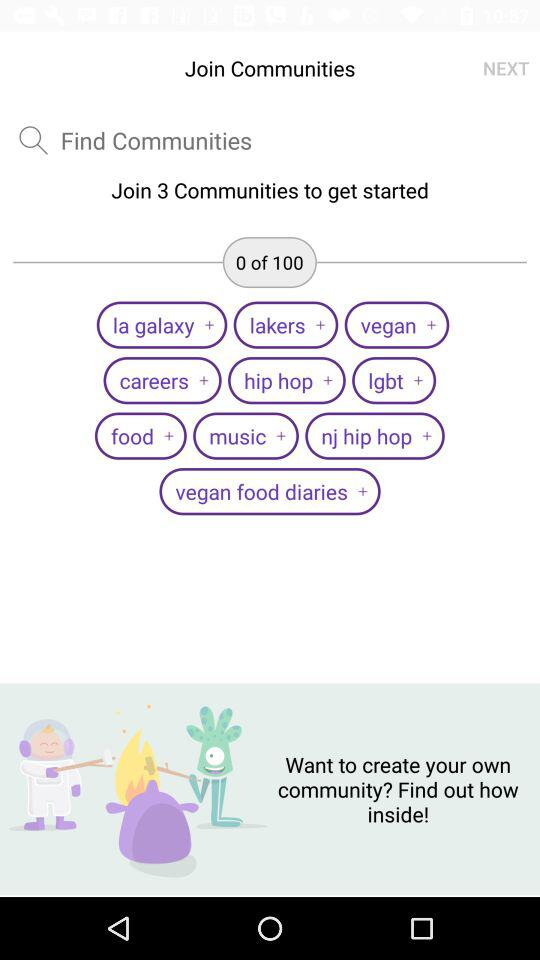How many communities do we need to join to get started? You need to join three communities to get started. 